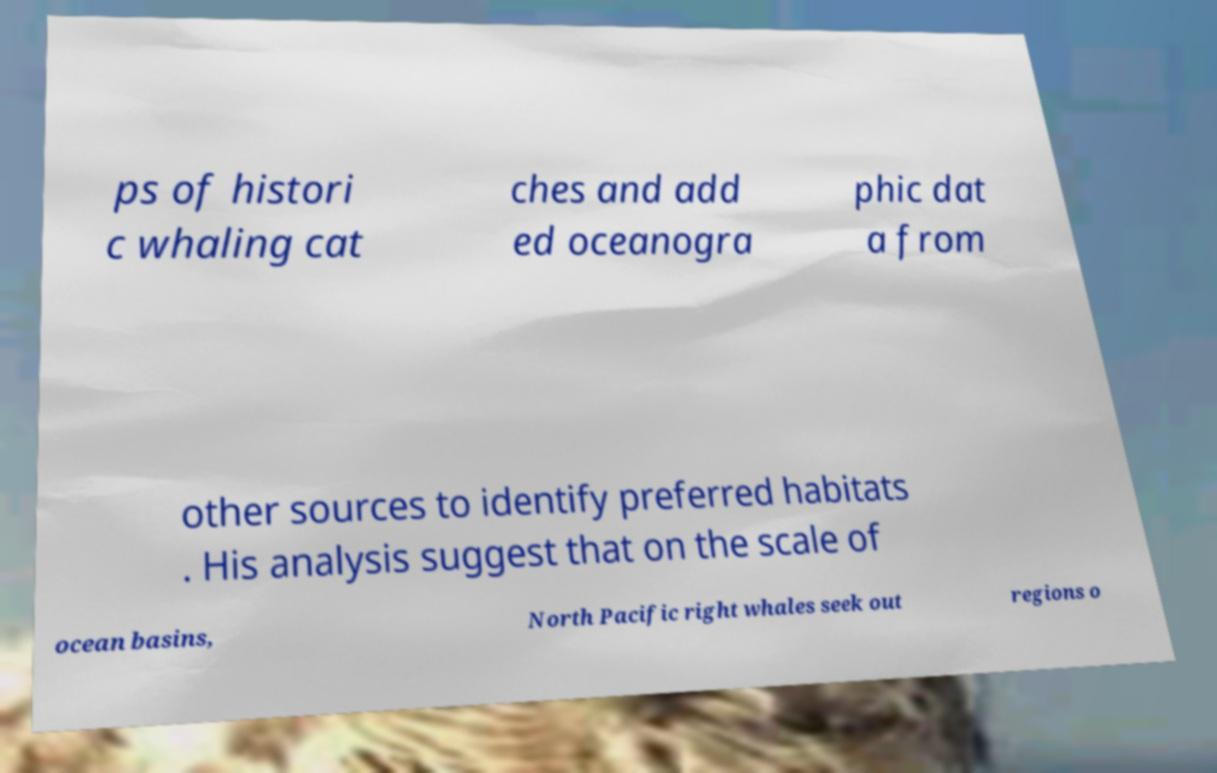Can you accurately transcribe the text from the provided image for me? ps of histori c whaling cat ches and add ed oceanogra phic dat a from other sources to identify preferred habitats . His analysis suggest that on the scale of ocean basins, North Pacific right whales seek out regions o 